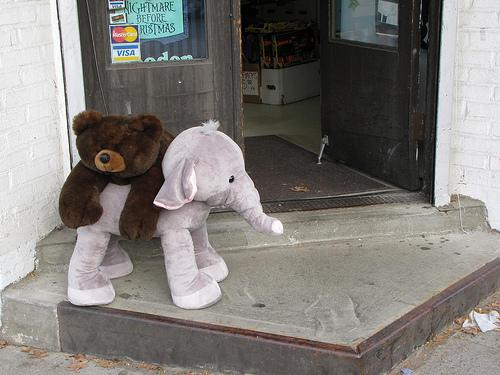Describe the ambiance of the location based on the image provided.  The image portrays a cozy atmosphere with some weathered elements, like the old door and concrete steps, contrasting the welcoming sight of stuffed animals and colorful credit card logos. Write a sentence from the perspective of a stuffed animal in the image. As the sun adorned the white brick wall behind us, we sat on the solid concrete steps, eagerly welcoming visitors into our cozy little home, the door holding the key to the magical world inside. Mention the most eye-catching element in the image. The stuffed animals, including a purple elephant and a brown teddy bear resting on the steps, stand out the most in the image. Describe the condition of the door and the brick wall in the image. The door appears old and worn, with a rusted hinge, while the brick wall, painted white, shows some signs of age and wear as well. Identify three objects in the image that pertain to the entrance of a store. Old wooden door, floor mat, and credit card logos displayed on the window. Provide a brief overview of the scene depicted in the image. The image shows various stuffed animals on a concrete step with a brick wall backdrop, an open door, and different credit card logos displayed on the window. Narrate a short story about this image using descriptive language. In a quaint little shop nestled between white-bricked walls, a faded purple elephant and a brown teddy bear eagerly wait for customers to arrive, while the worn-out door stands ajar, invitingly showcasing a colorful array of credit card logos. Explain the purpose of the object placed in front of the door. The floor mat provides a space for customers to wipe their feet before entering the store, keeping the interiors clean and tidy. List the main objects you observe in the image. Stuffed animals, concrete step, brick wall, old door, credit card logos, floor mat, cardboard box, rusted door hinge, and trash. What message does this image convey about the establishment? This image suggests a small, welcoming store with an artistic touch, evident by the display of charming stuffed animals in the entrance and the acceptance of various credit cards. 